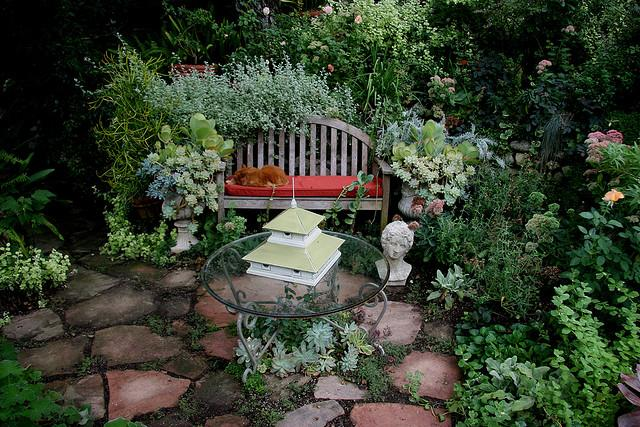What type of statue is to the right front of the bench? bust 